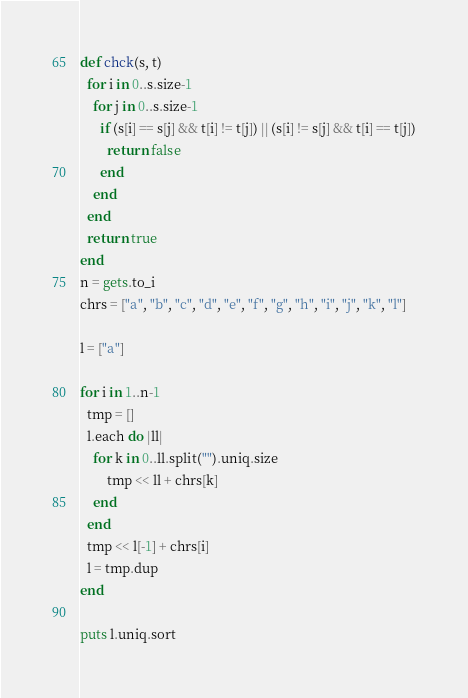Convert code to text. <code><loc_0><loc_0><loc_500><loc_500><_Ruby_>def chck(s, t)
  for i in 0..s.size-1
    for j in 0..s.size-1
      if (s[i] == s[j] && t[i] != t[j]) || (s[i] != s[j] && t[i] == t[j])
        return false
      end
    end
  end
  return true
end
n = gets.to_i
chrs = ["a", "b", "c", "d", "e", "f", "g", "h", "i", "j", "k", "l"]

l = ["a"]

for i in 1..n-1
  tmp = []
  l.each do |ll|
    for k in 0..ll.split("").uniq.size
        tmp << ll + chrs[k]
    end
  end
  tmp << l[-1] + chrs[i]
  l = tmp.dup
end

puts l.uniq.sort
</code> 